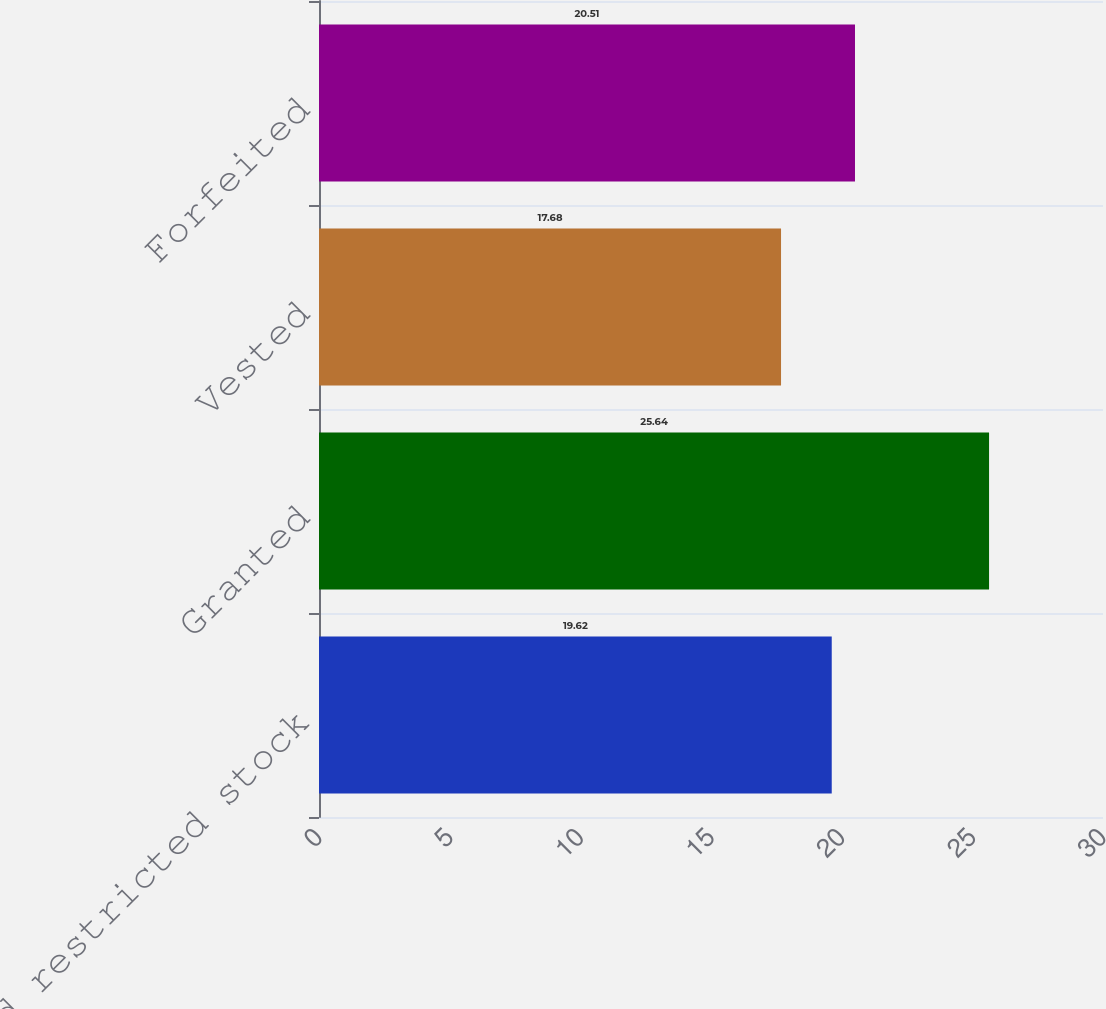Convert chart to OTSL. <chart><loc_0><loc_0><loc_500><loc_500><bar_chart><fcel>Unvested restricted stock<fcel>Granted<fcel>Vested<fcel>Forfeited<nl><fcel>19.62<fcel>25.64<fcel>17.68<fcel>20.51<nl></chart> 